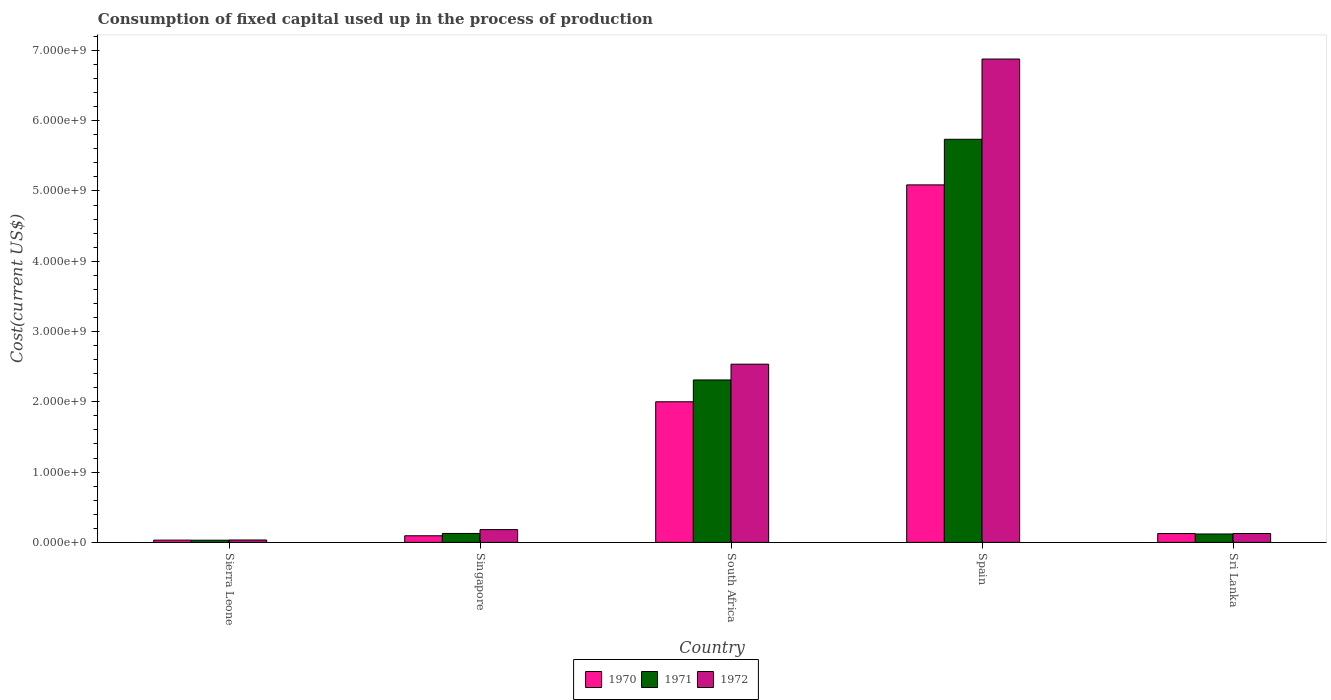How many different coloured bars are there?
Make the answer very short. 3. How many groups of bars are there?
Ensure brevity in your answer.  5. Are the number of bars on each tick of the X-axis equal?
Your answer should be very brief. Yes. How many bars are there on the 5th tick from the right?
Provide a short and direct response. 3. What is the label of the 1st group of bars from the left?
Keep it short and to the point. Sierra Leone. What is the amount consumed in the process of production in 1970 in Sri Lanka?
Ensure brevity in your answer.  1.26e+08. Across all countries, what is the maximum amount consumed in the process of production in 1971?
Provide a succinct answer. 5.74e+09. Across all countries, what is the minimum amount consumed in the process of production in 1970?
Your answer should be very brief. 3.22e+07. In which country was the amount consumed in the process of production in 1971 maximum?
Keep it short and to the point. Spain. In which country was the amount consumed in the process of production in 1972 minimum?
Keep it short and to the point. Sierra Leone. What is the total amount consumed in the process of production in 1970 in the graph?
Give a very brief answer. 7.34e+09. What is the difference between the amount consumed in the process of production in 1971 in Sierra Leone and that in South Africa?
Your answer should be very brief. -2.28e+09. What is the difference between the amount consumed in the process of production in 1971 in Sierra Leone and the amount consumed in the process of production in 1970 in Spain?
Provide a short and direct response. -5.06e+09. What is the average amount consumed in the process of production in 1972 per country?
Your response must be concise. 1.95e+09. What is the difference between the amount consumed in the process of production of/in 1970 and amount consumed in the process of production of/in 1972 in Sierra Leone?
Your answer should be very brief. -1.85e+06. In how many countries, is the amount consumed in the process of production in 1970 greater than 800000000 US$?
Your answer should be compact. 2. What is the ratio of the amount consumed in the process of production in 1972 in South Africa to that in Spain?
Your answer should be compact. 0.37. Is the amount consumed in the process of production in 1971 in Singapore less than that in South Africa?
Make the answer very short. Yes. What is the difference between the highest and the second highest amount consumed in the process of production in 1972?
Offer a terse response. 6.70e+09. What is the difference between the highest and the lowest amount consumed in the process of production in 1970?
Ensure brevity in your answer.  5.05e+09. Is the sum of the amount consumed in the process of production in 1970 in Singapore and Sri Lanka greater than the maximum amount consumed in the process of production in 1971 across all countries?
Ensure brevity in your answer.  No. What does the 2nd bar from the right in Sierra Leone represents?
Your response must be concise. 1971. Is it the case that in every country, the sum of the amount consumed in the process of production in 1972 and amount consumed in the process of production in 1971 is greater than the amount consumed in the process of production in 1970?
Make the answer very short. Yes. How many bars are there?
Your answer should be compact. 15. What is the difference between two consecutive major ticks on the Y-axis?
Your response must be concise. 1.00e+09. Are the values on the major ticks of Y-axis written in scientific E-notation?
Ensure brevity in your answer.  Yes. Does the graph contain grids?
Your answer should be very brief. No. How many legend labels are there?
Offer a very short reply. 3. How are the legend labels stacked?
Your answer should be very brief. Horizontal. What is the title of the graph?
Offer a very short reply. Consumption of fixed capital used up in the process of production. Does "1997" appear as one of the legend labels in the graph?
Offer a terse response. No. What is the label or title of the Y-axis?
Your response must be concise. Cost(current US$). What is the Cost(current US$) in 1970 in Sierra Leone?
Keep it short and to the point. 3.22e+07. What is the Cost(current US$) of 1971 in Sierra Leone?
Your response must be concise. 3.10e+07. What is the Cost(current US$) of 1972 in Sierra Leone?
Offer a very short reply. 3.40e+07. What is the Cost(current US$) in 1970 in Singapore?
Provide a succinct answer. 9.40e+07. What is the Cost(current US$) in 1971 in Singapore?
Your response must be concise. 1.27e+08. What is the Cost(current US$) in 1972 in Singapore?
Your response must be concise. 1.82e+08. What is the Cost(current US$) in 1970 in South Africa?
Make the answer very short. 2.00e+09. What is the Cost(current US$) of 1971 in South Africa?
Provide a short and direct response. 2.31e+09. What is the Cost(current US$) in 1972 in South Africa?
Ensure brevity in your answer.  2.54e+09. What is the Cost(current US$) in 1970 in Spain?
Make the answer very short. 5.09e+09. What is the Cost(current US$) in 1971 in Spain?
Offer a very short reply. 5.74e+09. What is the Cost(current US$) of 1972 in Spain?
Your answer should be compact. 6.88e+09. What is the Cost(current US$) in 1970 in Sri Lanka?
Offer a terse response. 1.26e+08. What is the Cost(current US$) in 1971 in Sri Lanka?
Make the answer very short. 1.20e+08. What is the Cost(current US$) of 1972 in Sri Lanka?
Keep it short and to the point. 1.26e+08. Across all countries, what is the maximum Cost(current US$) of 1970?
Offer a terse response. 5.09e+09. Across all countries, what is the maximum Cost(current US$) in 1971?
Keep it short and to the point. 5.74e+09. Across all countries, what is the maximum Cost(current US$) in 1972?
Your answer should be compact. 6.88e+09. Across all countries, what is the minimum Cost(current US$) in 1970?
Give a very brief answer. 3.22e+07. Across all countries, what is the minimum Cost(current US$) of 1971?
Offer a terse response. 3.10e+07. Across all countries, what is the minimum Cost(current US$) in 1972?
Offer a very short reply. 3.40e+07. What is the total Cost(current US$) in 1970 in the graph?
Offer a terse response. 7.34e+09. What is the total Cost(current US$) of 1971 in the graph?
Give a very brief answer. 8.32e+09. What is the total Cost(current US$) in 1972 in the graph?
Give a very brief answer. 9.75e+09. What is the difference between the Cost(current US$) of 1970 in Sierra Leone and that in Singapore?
Provide a short and direct response. -6.18e+07. What is the difference between the Cost(current US$) in 1971 in Sierra Leone and that in Singapore?
Ensure brevity in your answer.  -9.62e+07. What is the difference between the Cost(current US$) of 1972 in Sierra Leone and that in Singapore?
Your response must be concise. -1.48e+08. What is the difference between the Cost(current US$) in 1970 in Sierra Leone and that in South Africa?
Offer a very short reply. -1.97e+09. What is the difference between the Cost(current US$) in 1971 in Sierra Leone and that in South Africa?
Your response must be concise. -2.28e+09. What is the difference between the Cost(current US$) in 1972 in Sierra Leone and that in South Africa?
Your response must be concise. -2.50e+09. What is the difference between the Cost(current US$) of 1970 in Sierra Leone and that in Spain?
Ensure brevity in your answer.  -5.05e+09. What is the difference between the Cost(current US$) of 1971 in Sierra Leone and that in Spain?
Provide a succinct answer. -5.70e+09. What is the difference between the Cost(current US$) in 1972 in Sierra Leone and that in Spain?
Your answer should be very brief. -6.84e+09. What is the difference between the Cost(current US$) of 1970 in Sierra Leone and that in Sri Lanka?
Provide a succinct answer. -9.34e+07. What is the difference between the Cost(current US$) in 1971 in Sierra Leone and that in Sri Lanka?
Provide a short and direct response. -8.86e+07. What is the difference between the Cost(current US$) in 1972 in Sierra Leone and that in Sri Lanka?
Keep it short and to the point. -9.23e+07. What is the difference between the Cost(current US$) of 1970 in Singapore and that in South Africa?
Offer a very short reply. -1.91e+09. What is the difference between the Cost(current US$) of 1971 in Singapore and that in South Africa?
Give a very brief answer. -2.18e+09. What is the difference between the Cost(current US$) in 1972 in Singapore and that in South Africa?
Provide a short and direct response. -2.35e+09. What is the difference between the Cost(current US$) in 1970 in Singapore and that in Spain?
Your response must be concise. -4.99e+09. What is the difference between the Cost(current US$) of 1971 in Singapore and that in Spain?
Provide a short and direct response. -5.61e+09. What is the difference between the Cost(current US$) of 1972 in Singapore and that in Spain?
Ensure brevity in your answer.  -6.70e+09. What is the difference between the Cost(current US$) in 1970 in Singapore and that in Sri Lanka?
Keep it short and to the point. -3.15e+07. What is the difference between the Cost(current US$) of 1971 in Singapore and that in Sri Lanka?
Your answer should be very brief. 7.62e+06. What is the difference between the Cost(current US$) of 1972 in Singapore and that in Sri Lanka?
Ensure brevity in your answer.  5.54e+07. What is the difference between the Cost(current US$) in 1970 in South Africa and that in Spain?
Keep it short and to the point. -3.09e+09. What is the difference between the Cost(current US$) of 1971 in South Africa and that in Spain?
Give a very brief answer. -3.42e+09. What is the difference between the Cost(current US$) in 1972 in South Africa and that in Spain?
Your answer should be compact. -4.34e+09. What is the difference between the Cost(current US$) of 1970 in South Africa and that in Sri Lanka?
Offer a very short reply. 1.88e+09. What is the difference between the Cost(current US$) in 1971 in South Africa and that in Sri Lanka?
Offer a very short reply. 2.19e+09. What is the difference between the Cost(current US$) in 1972 in South Africa and that in Sri Lanka?
Keep it short and to the point. 2.41e+09. What is the difference between the Cost(current US$) of 1970 in Spain and that in Sri Lanka?
Provide a short and direct response. 4.96e+09. What is the difference between the Cost(current US$) of 1971 in Spain and that in Sri Lanka?
Keep it short and to the point. 5.62e+09. What is the difference between the Cost(current US$) in 1972 in Spain and that in Sri Lanka?
Your answer should be very brief. 6.75e+09. What is the difference between the Cost(current US$) in 1970 in Sierra Leone and the Cost(current US$) in 1971 in Singapore?
Make the answer very short. -9.50e+07. What is the difference between the Cost(current US$) in 1970 in Sierra Leone and the Cost(current US$) in 1972 in Singapore?
Offer a terse response. -1.50e+08. What is the difference between the Cost(current US$) of 1971 in Sierra Leone and the Cost(current US$) of 1972 in Singapore?
Your response must be concise. -1.51e+08. What is the difference between the Cost(current US$) of 1970 in Sierra Leone and the Cost(current US$) of 1971 in South Africa?
Offer a terse response. -2.28e+09. What is the difference between the Cost(current US$) in 1970 in Sierra Leone and the Cost(current US$) in 1972 in South Africa?
Your answer should be very brief. -2.50e+09. What is the difference between the Cost(current US$) of 1971 in Sierra Leone and the Cost(current US$) of 1972 in South Africa?
Make the answer very short. -2.50e+09. What is the difference between the Cost(current US$) of 1970 in Sierra Leone and the Cost(current US$) of 1971 in Spain?
Your response must be concise. -5.70e+09. What is the difference between the Cost(current US$) in 1970 in Sierra Leone and the Cost(current US$) in 1972 in Spain?
Your answer should be very brief. -6.85e+09. What is the difference between the Cost(current US$) of 1971 in Sierra Leone and the Cost(current US$) of 1972 in Spain?
Offer a terse response. -6.85e+09. What is the difference between the Cost(current US$) of 1970 in Sierra Leone and the Cost(current US$) of 1971 in Sri Lanka?
Keep it short and to the point. -8.74e+07. What is the difference between the Cost(current US$) of 1970 in Sierra Leone and the Cost(current US$) of 1972 in Sri Lanka?
Your response must be concise. -9.42e+07. What is the difference between the Cost(current US$) in 1971 in Sierra Leone and the Cost(current US$) in 1972 in Sri Lanka?
Your response must be concise. -9.53e+07. What is the difference between the Cost(current US$) in 1970 in Singapore and the Cost(current US$) in 1971 in South Africa?
Your answer should be compact. -2.22e+09. What is the difference between the Cost(current US$) in 1970 in Singapore and the Cost(current US$) in 1972 in South Africa?
Provide a succinct answer. -2.44e+09. What is the difference between the Cost(current US$) in 1971 in Singapore and the Cost(current US$) in 1972 in South Africa?
Your response must be concise. -2.41e+09. What is the difference between the Cost(current US$) of 1970 in Singapore and the Cost(current US$) of 1971 in Spain?
Your answer should be very brief. -5.64e+09. What is the difference between the Cost(current US$) in 1970 in Singapore and the Cost(current US$) in 1972 in Spain?
Your answer should be very brief. -6.78e+09. What is the difference between the Cost(current US$) in 1971 in Singapore and the Cost(current US$) in 1972 in Spain?
Your answer should be very brief. -6.75e+09. What is the difference between the Cost(current US$) in 1970 in Singapore and the Cost(current US$) in 1971 in Sri Lanka?
Offer a terse response. -2.56e+07. What is the difference between the Cost(current US$) in 1970 in Singapore and the Cost(current US$) in 1972 in Sri Lanka?
Your answer should be compact. -3.23e+07. What is the difference between the Cost(current US$) in 1971 in Singapore and the Cost(current US$) in 1972 in Sri Lanka?
Offer a terse response. 8.64e+05. What is the difference between the Cost(current US$) of 1970 in South Africa and the Cost(current US$) of 1971 in Spain?
Ensure brevity in your answer.  -3.73e+09. What is the difference between the Cost(current US$) in 1970 in South Africa and the Cost(current US$) in 1972 in Spain?
Your response must be concise. -4.88e+09. What is the difference between the Cost(current US$) of 1971 in South Africa and the Cost(current US$) of 1972 in Spain?
Provide a succinct answer. -4.57e+09. What is the difference between the Cost(current US$) in 1970 in South Africa and the Cost(current US$) in 1971 in Sri Lanka?
Your answer should be compact. 1.88e+09. What is the difference between the Cost(current US$) in 1970 in South Africa and the Cost(current US$) in 1972 in Sri Lanka?
Your answer should be compact. 1.87e+09. What is the difference between the Cost(current US$) in 1971 in South Africa and the Cost(current US$) in 1972 in Sri Lanka?
Make the answer very short. 2.18e+09. What is the difference between the Cost(current US$) in 1970 in Spain and the Cost(current US$) in 1971 in Sri Lanka?
Offer a very short reply. 4.97e+09. What is the difference between the Cost(current US$) in 1970 in Spain and the Cost(current US$) in 1972 in Sri Lanka?
Your response must be concise. 4.96e+09. What is the difference between the Cost(current US$) in 1971 in Spain and the Cost(current US$) in 1972 in Sri Lanka?
Offer a terse response. 5.61e+09. What is the average Cost(current US$) of 1970 per country?
Keep it short and to the point. 1.47e+09. What is the average Cost(current US$) of 1971 per country?
Offer a terse response. 1.66e+09. What is the average Cost(current US$) in 1972 per country?
Offer a very short reply. 1.95e+09. What is the difference between the Cost(current US$) of 1970 and Cost(current US$) of 1971 in Sierra Leone?
Your answer should be very brief. 1.15e+06. What is the difference between the Cost(current US$) in 1970 and Cost(current US$) in 1972 in Sierra Leone?
Your response must be concise. -1.85e+06. What is the difference between the Cost(current US$) of 1971 and Cost(current US$) of 1972 in Sierra Leone?
Your answer should be compact. -3.00e+06. What is the difference between the Cost(current US$) in 1970 and Cost(current US$) in 1971 in Singapore?
Give a very brief answer. -3.32e+07. What is the difference between the Cost(current US$) in 1970 and Cost(current US$) in 1972 in Singapore?
Provide a succinct answer. -8.77e+07. What is the difference between the Cost(current US$) of 1971 and Cost(current US$) of 1972 in Singapore?
Your answer should be very brief. -5.45e+07. What is the difference between the Cost(current US$) in 1970 and Cost(current US$) in 1971 in South Africa?
Offer a very short reply. -3.11e+08. What is the difference between the Cost(current US$) of 1970 and Cost(current US$) of 1972 in South Africa?
Make the answer very short. -5.35e+08. What is the difference between the Cost(current US$) in 1971 and Cost(current US$) in 1972 in South Africa?
Provide a short and direct response. -2.24e+08. What is the difference between the Cost(current US$) of 1970 and Cost(current US$) of 1971 in Spain?
Your answer should be compact. -6.49e+08. What is the difference between the Cost(current US$) of 1970 and Cost(current US$) of 1972 in Spain?
Your answer should be very brief. -1.79e+09. What is the difference between the Cost(current US$) in 1971 and Cost(current US$) in 1972 in Spain?
Keep it short and to the point. -1.14e+09. What is the difference between the Cost(current US$) of 1970 and Cost(current US$) of 1971 in Sri Lanka?
Provide a short and direct response. 5.97e+06. What is the difference between the Cost(current US$) in 1970 and Cost(current US$) in 1972 in Sri Lanka?
Keep it short and to the point. -7.92e+05. What is the difference between the Cost(current US$) in 1971 and Cost(current US$) in 1972 in Sri Lanka?
Provide a short and direct response. -6.76e+06. What is the ratio of the Cost(current US$) in 1970 in Sierra Leone to that in Singapore?
Your response must be concise. 0.34. What is the ratio of the Cost(current US$) in 1971 in Sierra Leone to that in Singapore?
Offer a terse response. 0.24. What is the ratio of the Cost(current US$) of 1972 in Sierra Leone to that in Singapore?
Keep it short and to the point. 0.19. What is the ratio of the Cost(current US$) of 1970 in Sierra Leone to that in South Africa?
Give a very brief answer. 0.02. What is the ratio of the Cost(current US$) in 1971 in Sierra Leone to that in South Africa?
Your response must be concise. 0.01. What is the ratio of the Cost(current US$) of 1972 in Sierra Leone to that in South Africa?
Your answer should be compact. 0.01. What is the ratio of the Cost(current US$) of 1970 in Sierra Leone to that in Spain?
Provide a short and direct response. 0.01. What is the ratio of the Cost(current US$) of 1971 in Sierra Leone to that in Spain?
Offer a terse response. 0.01. What is the ratio of the Cost(current US$) in 1972 in Sierra Leone to that in Spain?
Offer a very short reply. 0. What is the ratio of the Cost(current US$) of 1970 in Sierra Leone to that in Sri Lanka?
Give a very brief answer. 0.26. What is the ratio of the Cost(current US$) of 1971 in Sierra Leone to that in Sri Lanka?
Make the answer very short. 0.26. What is the ratio of the Cost(current US$) of 1972 in Sierra Leone to that in Sri Lanka?
Keep it short and to the point. 0.27. What is the ratio of the Cost(current US$) in 1970 in Singapore to that in South Africa?
Offer a terse response. 0.05. What is the ratio of the Cost(current US$) in 1971 in Singapore to that in South Africa?
Provide a short and direct response. 0.06. What is the ratio of the Cost(current US$) in 1972 in Singapore to that in South Africa?
Offer a terse response. 0.07. What is the ratio of the Cost(current US$) in 1970 in Singapore to that in Spain?
Offer a very short reply. 0.02. What is the ratio of the Cost(current US$) in 1971 in Singapore to that in Spain?
Give a very brief answer. 0.02. What is the ratio of the Cost(current US$) in 1972 in Singapore to that in Spain?
Offer a terse response. 0.03. What is the ratio of the Cost(current US$) of 1970 in Singapore to that in Sri Lanka?
Ensure brevity in your answer.  0.75. What is the ratio of the Cost(current US$) in 1971 in Singapore to that in Sri Lanka?
Provide a succinct answer. 1.06. What is the ratio of the Cost(current US$) in 1972 in Singapore to that in Sri Lanka?
Give a very brief answer. 1.44. What is the ratio of the Cost(current US$) in 1970 in South Africa to that in Spain?
Your answer should be compact. 0.39. What is the ratio of the Cost(current US$) of 1971 in South Africa to that in Spain?
Provide a short and direct response. 0.4. What is the ratio of the Cost(current US$) in 1972 in South Africa to that in Spain?
Your answer should be very brief. 0.37. What is the ratio of the Cost(current US$) in 1970 in South Africa to that in Sri Lanka?
Make the answer very short. 15.93. What is the ratio of the Cost(current US$) of 1971 in South Africa to that in Sri Lanka?
Offer a very short reply. 19.32. What is the ratio of the Cost(current US$) in 1972 in South Africa to that in Sri Lanka?
Give a very brief answer. 20.07. What is the ratio of the Cost(current US$) of 1970 in Spain to that in Sri Lanka?
Your response must be concise. 40.51. What is the ratio of the Cost(current US$) of 1971 in Spain to that in Sri Lanka?
Offer a terse response. 47.96. What is the ratio of the Cost(current US$) of 1972 in Spain to that in Sri Lanka?
Give a very brief answer. 54.43. What is the difference between the highest and the second highest Cost(current US$) in 1970?
Provide a short and direct response. 3.09e+09. What is the difference between the highest and the second highest Cost(current US$) of 1971?
Keep it short and to the point. 3.42e+09. What is the difference between the highest and the second highest Cost(current US$) in 1972?
Give a very brief answer. 4.34e+09. What is the difference between the highest and the lowest Cost(current US$) of 1970?
Provide a short and direct response. 5.05e+09. What is the difference between the highest and the lowest Cost(current US$) in 1971?
Offer a terse response. 5.70e+09. What is the difference between the highest and the lowest Cost(current US$) of 1972?
Your answer should be compact. 6.84e+09. 